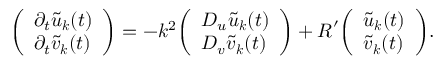Convert formula to latex. <formula><loc_0><loc_0><loc_500><loc_500>{ \left ( \begin{array} { l } { \partial _ { t } { \tilde { u } } _ { k } ( t ) } \\ { \partial _ { t } { \tilde { v } } _ { k } ( t ) } \end{array} \right ) } = - k ^ { 2 } { \left ( \begin{array} { l } { D _ { u } { \tilde { u } } _ { k } ( t ) } \\ { D _ { v } { \tilde { v } } _ { k } ( t ) } \end{array} \right ) } + { R } ^ { \prime } { \left ( \begin{array} { l } { { \tilde { u } } _ { k } ( t ) } \\ { { \tilde { v } } _ { k } ( t ) } \end{array} \right ) } .</formula> 